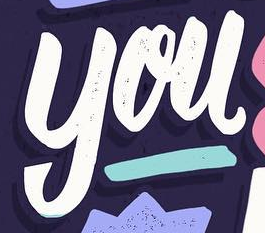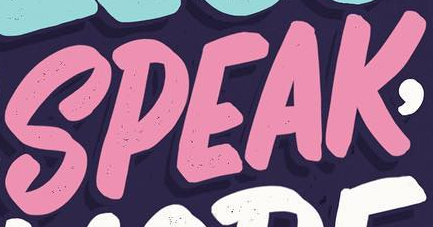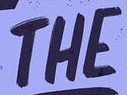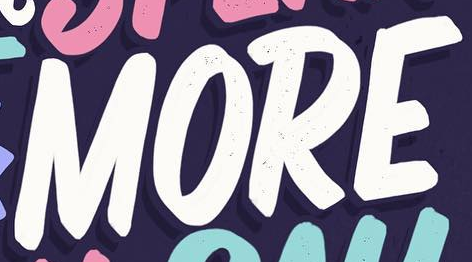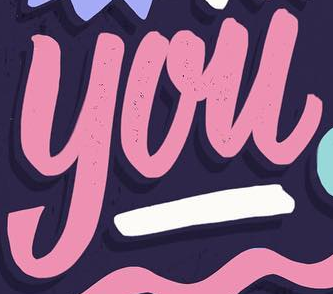What text is displayed in these images sequentially, separated by a semicolon? you; SPEAK; THE; MORE; you 